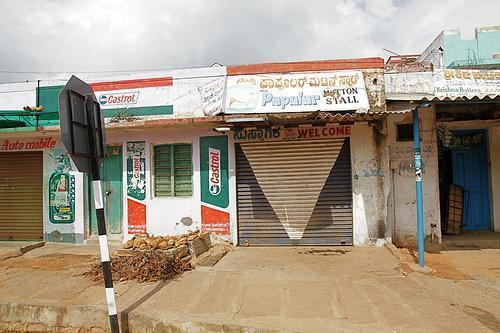How many people can be seen?
Give a very brief answer. 0. 